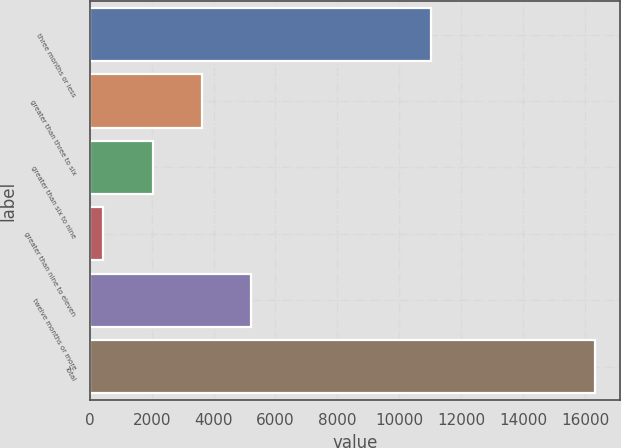<chart> <loc_0><loc_0><loc_500><loc_500><bar_chart><fcel>three months or less<fcel>greater than three to six<fcel>greater than six to nine<fcel>greater than nine to eleven<fcel>twelve months or more<fcel>Total<nl><fcel>11037<fcel>3615.6<fcel>2028.3<fcel>441<fcel>5202.9<fcel>16314<nl></chart> 